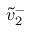Convert formula to latex. <formula><loc_0><loc_0><loc_500><loc_500>\tilde { v } _ { 2 } ^ { - }</formula> 